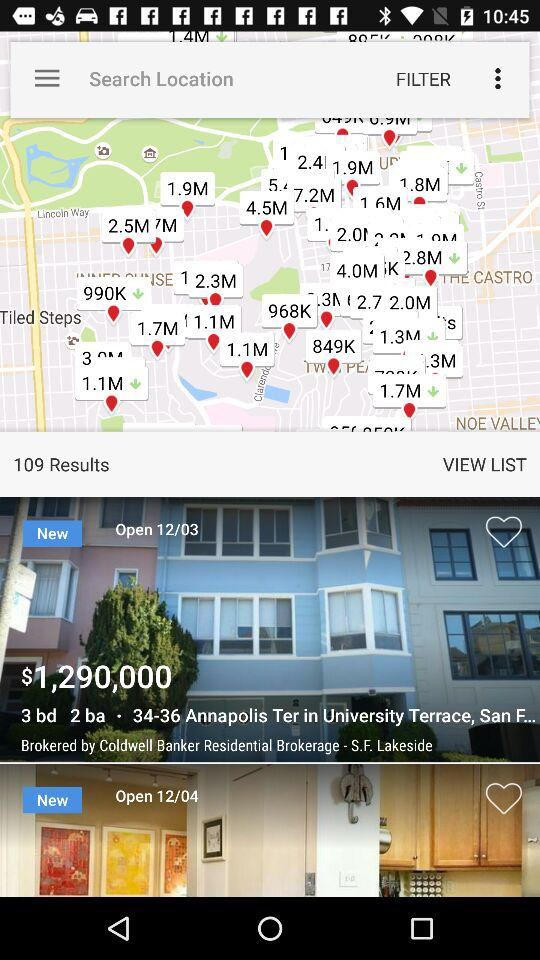How many results are shown on the screen? The shown result is 109. 